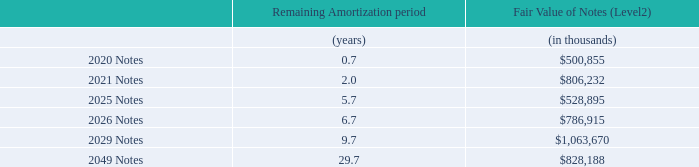Senior Notes
On March 4, 2019, the company completed a public offering of $750 million aggregate principal amount of the Company’s Senior Notes due March 15, 2026 (the “2026 Notes”), $1.0 billion aggregate principal amount of the Company’s Senior Notes due March 15, 2029 (the “2029 Notes”), and $750 million aggregate principal amount of the Company’s Senior Notes due March 15, 2049 (the “2049 Notes”). The Company will pay interest at an annual rate of 3.75%, 4.00%, and 4.875%, on the 2026, 2029, and 2049 Notes, respectively, on a semi-annual basis on March 15 and September 15 of each year beginning September 15, 2019.
On March 12, 2015, the Company completed a public offering of $500 million aggregate principal amount of the Company’s Senior Notes due March 15, 2020 (the “2020 Notes”) and $500 million aggregate principal amount of the Company’s Senior Notes due March 15, 2025 (the “2025 Notes”). The Company pays interest at an annual rate of 2.75% and 3.80% on the 2020 Notes and 2025 Notes, respectively, on a semi-annual basis on March 15 and September 15 of each year. During the year ended June 26, 2016, the Company entered into a series of interest rate contracts hedging the fair value of a portion of the 2025 Notes par value, whereby the Company receives a fixed rate and pays a variable rate based on a certain benchmark interest rate. Refer to Note 9— Financial Instruments for additional information regarding these interest rate contracts.
On June 7, 2016, the Company completed a public offering of $800 million aggregate principal amount of Senior Notes due June 2021 (the “2021 Notes”). The Company pays interest at an annual rate of 2.80% on the 2021 Notes on a semi-annual basis on June 15 and December 15 of each year.
The Company may redeem the 2020, 2021, 2025, 2026, 2029 and 2049 Notes (collectively the “Senior Notes”) at a redemption price equal to 100% of the principal amount of such series (“par”), plus a “make whole” premium as described in the indenture in respect to the Senior Notes and accrued and unpaid interest before February 15, 2020, for the 2020 Notes, before May 15, 2021 for the 2021 Notes, before December 15, 2024 for the 2025 Notes, before January 15, 2026 for the 2026 Notes, before December 15, 2028 for the 2029 Notes, and before September 15, 2048 for the 2049 Notes. The Company may redeem the Senior Notes at par, plus accrued and unpaid interest at any time on or after February 15, 2020, for the 2020 Notes, on or after May 15, 2021 for the 2021 Notes, on or after December 24, 2024, for the 2025 Notes, on or after January 15, 2026 for the 2026 Notes, on or after December 15, 2028 for the 2029 Notes, and on or after September 15, 2048 for the 2049 Notes. In addition, upon the occurrence of certain events, as described in the indenture, the Company will be required to make an offer to repurchase the Senior Notes at a price equal to 101% of the principal amount of the respective note, plus accrued and unpaid interest.
Selected additional information regarding the Senior Notes outstanding as of June 30, 2019, is as follows:
What is the annual interest rate the Company will pay on the 2026 Notes? 3.75%. What is the aggregate principal amount of Senior Notes due June 2021? $800 million. What is the interest at annual rate that the Company will pay on the 2021 Notes? 2.80%. Which notes has the highest fair value? Find the Notes with the highest fair value
Answer: 2029. Which notes has the highest remaining amortization period? Find the Notes with the highest remaining amortization period
Answer: 2049. What is the annual interest expense on the 2021 Notes?
Answer scale should be: million. 800*2.80%
Answer: 22.4. 